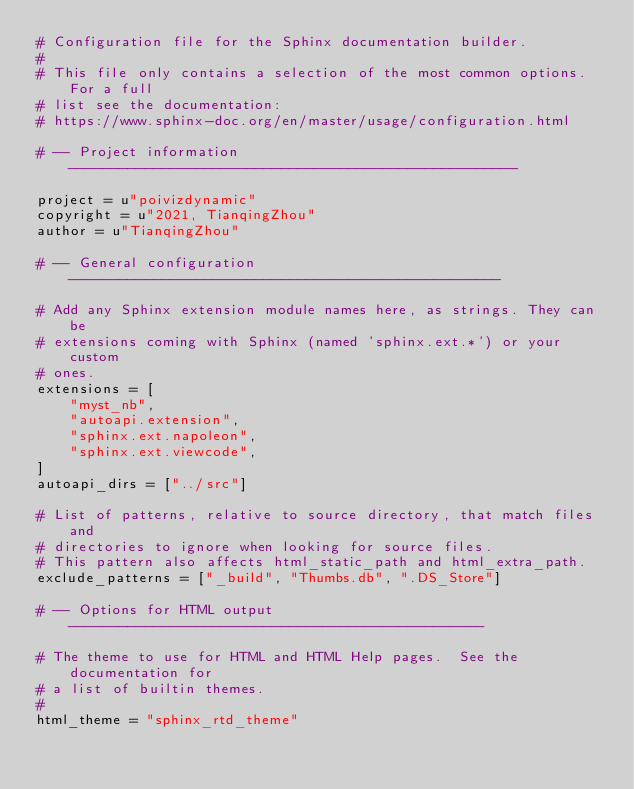Convert code to text. <code><loc_0><loc_0><loc_500><loc_500><_Python_># Configuration file for the Sphinx documentation builder.
#
# This file only contains a selection of the most common options. For a full
# list see the documentation:
# https://www.sphinx-doc.org/en/master/usage/configuration.html

# -- Project information -----------------------------------------------------

project = u"poivizdynamic"
copyright = u"2021, TianqingZhou"
author = u"TianqingZhou"

# -- General configuration ---------------------------------------------------

# Add any Sphinx extension module names here, as strings. They can be
# extensions coming with Sphinx (named 'sphinx.ext.*') or your custom
# ones.
extensions = [
    "myst_nb",
    "autoapi.extension",
    "sphinx.ext.napoleon",
    "sphinx.ext.viewcode",
]
autoapi_dirs = ["../src"]

# List of patterns, relative to source directory, that match files and
# directories to ignore when looking for source files.
# This pattern also affects html_static_path and html_extra_path.
exclude_patterns = ["_build", "Thumbs.db", ".DS_Store"]

# -- Options for HTML output -------------------------------------------------

# The theme to use for HTML and HTML Help pages.  See the documentation for
# a list of builtin themes.
#
html_theme = "sphinx_rtd_theme"
</code> 